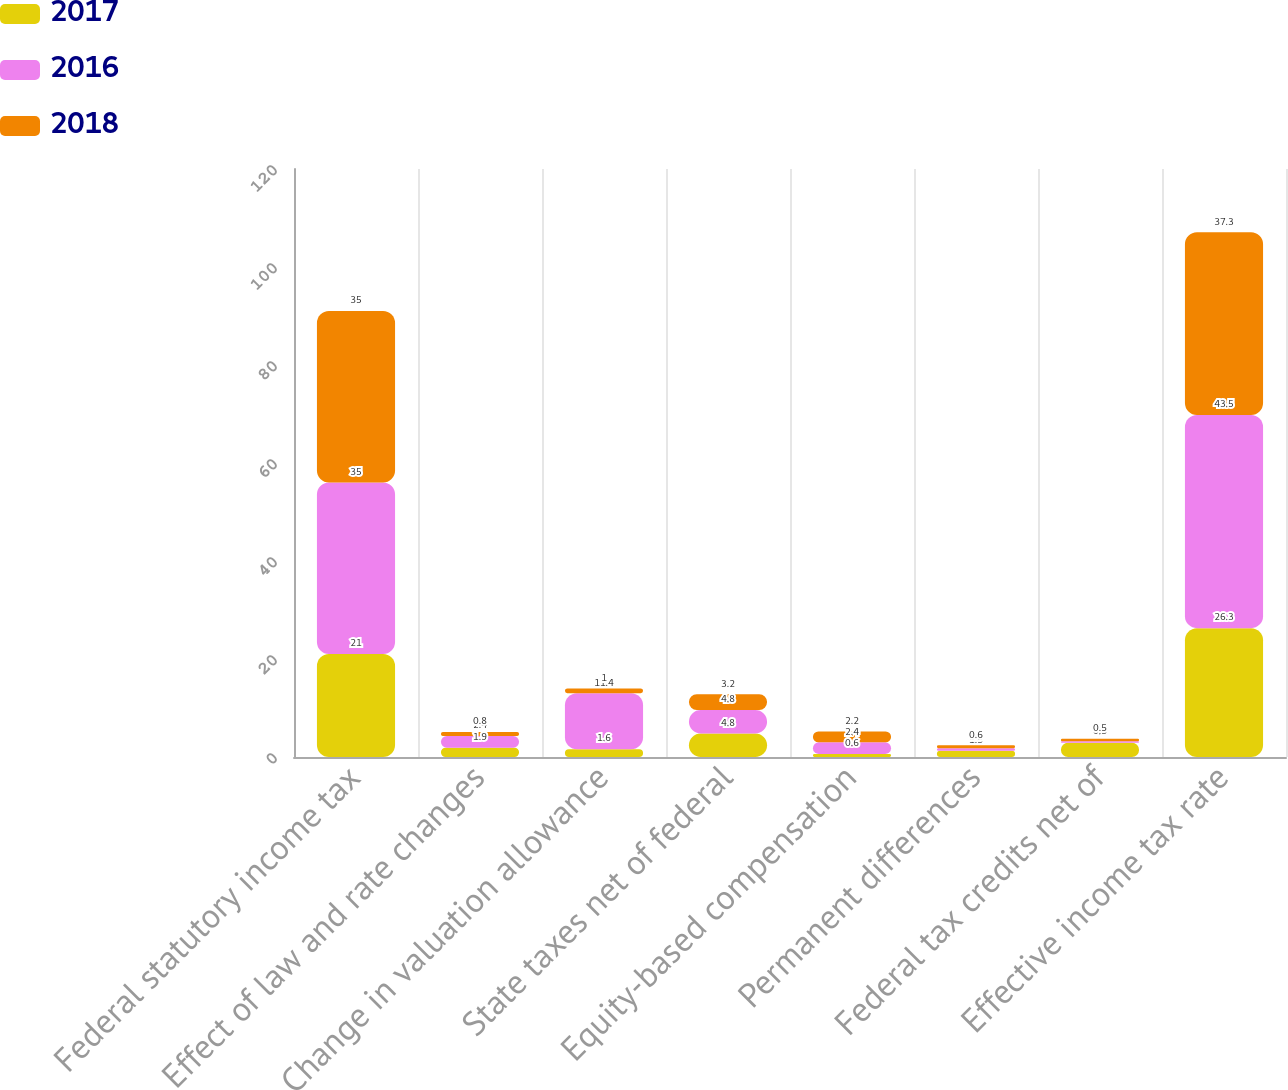Convert chart to OTSL. <chart><loc_0><loc_0><loc_500><loc_500><stacked_bar_chart><ecel><fcel>Federal statutory income tax<fcel>Effect of law and rate changes<fcel>Change in valuation allowance<fcel>State taxes net of federal<fcel>Equity-based compensation<fcel>Permanent differences<fcel>Federal tax credits net of<fcel>Effective income tax rate<nl><fcel>2017<fcel>21<fcel>1.9<fcel>1.6<fcel>4.8<fcel>0.6<fcel>1.3<fcel>2.9<fcel>26.3<nl><fcel>2016<fcel>35<fcel>2.4<fcel>11.4<fcel>4.8<fcel>2.4<fcel>0.5<fcel>0.3<fcel>43.5<nl><fcel>2018<fcel>35<fcel>0.8<fcel>1<fcel>3.2<fcel>2.2<fcel>0.6<fcel>0.5<fcel>37.3<nl></chart> 